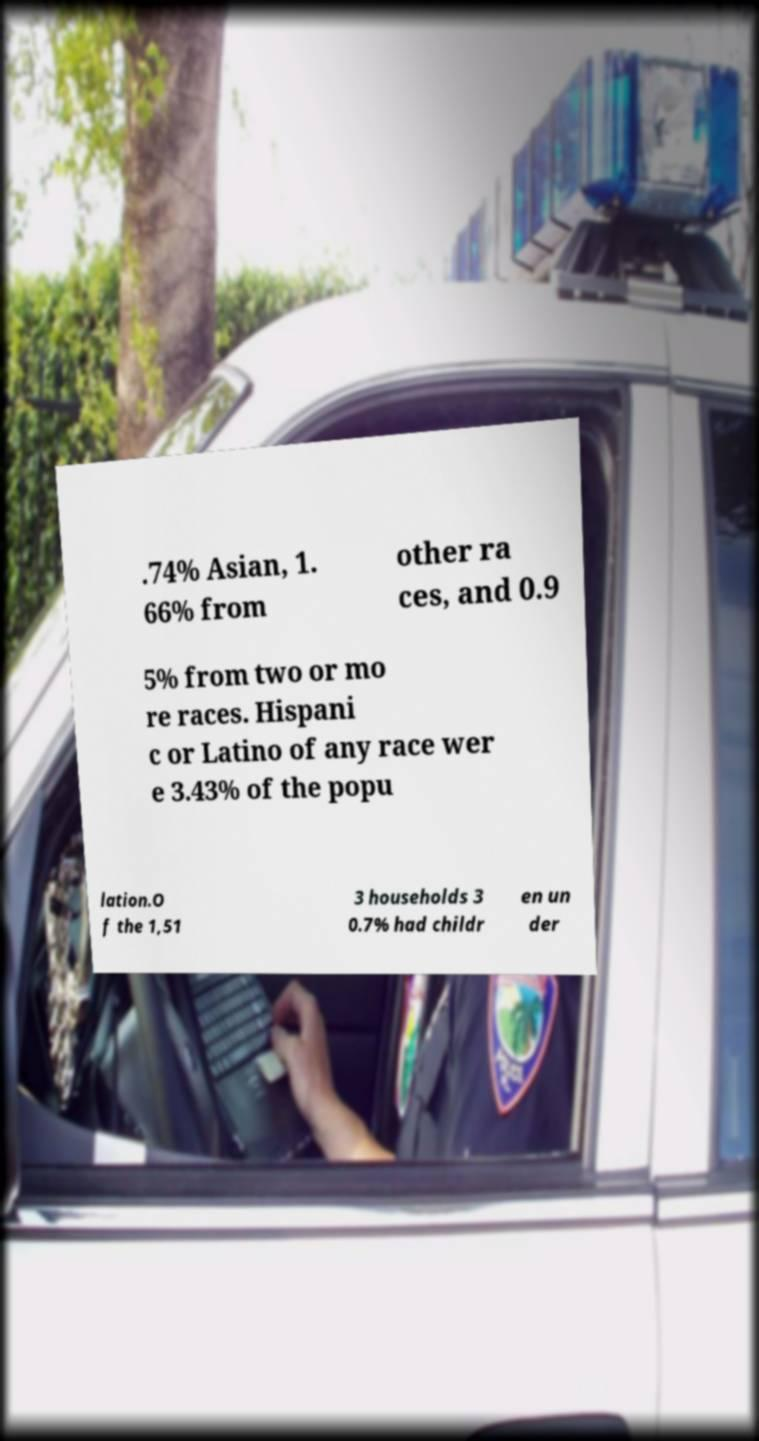Can you accurately transcribe the text from the provided image for me? .74% Asian, 1. 66% from other ra ces, and 0.9 5% from two or mo re races. Hispani c or Latino of any race wer e 3.43% of the popu lation.O f the 1,51 3 households 3 0.7% had childr en un der 